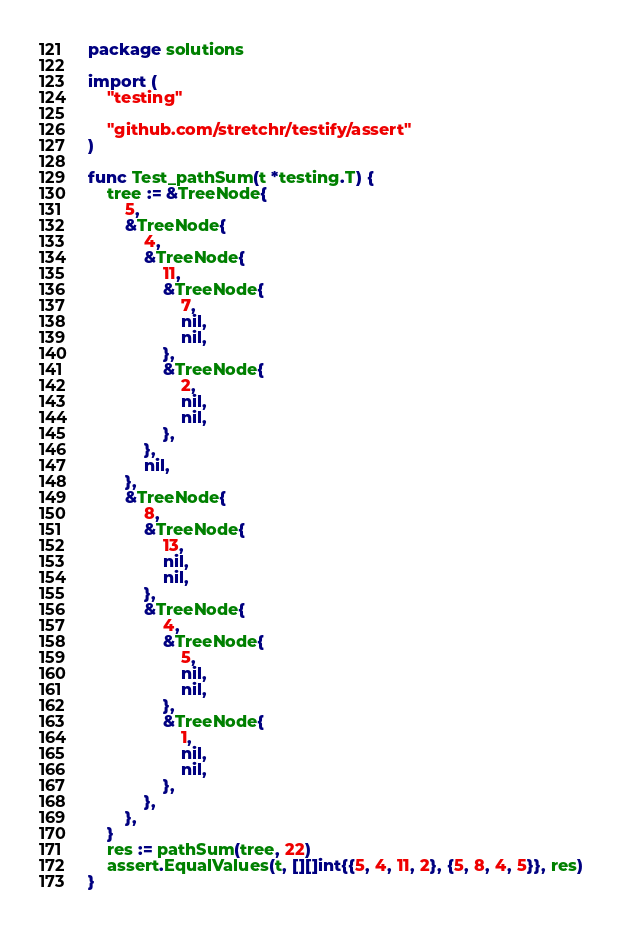<code> <loc_0><loc_0><loc_500><loc_500><_Go_>package solutions

import (
	"testing"

	"github.com/stretchr/testify/assert"
)

func Test_pathSum(t *testing.T) {
	tree := &TreeNode{
		5,
		&TreeNode{
			4,
			&TreeNode{
				11,
				&TreeNode{
					7,
					nil,
					nil,
				},
				&TreeNode{
					2,
					nil,
					nil,
				},
			},
			nil,
		},
		&TreeNode{
			8,
			&TreeNode{
				13,
				nil,
				nil,
			},
			&TreeNode{
				4,
				&TreeNode{
					5,
					nil,
					nil,
				},
				&TreeNode{
					1,
					nil,
					nil,
				},
			},
		},
	}
	res := pathSum(tree, 22)
	assert.EqualValues(t, [][]int{{5, 4, 11, 2}, {5, 8, 4, 5}}, res)
}
</code> 